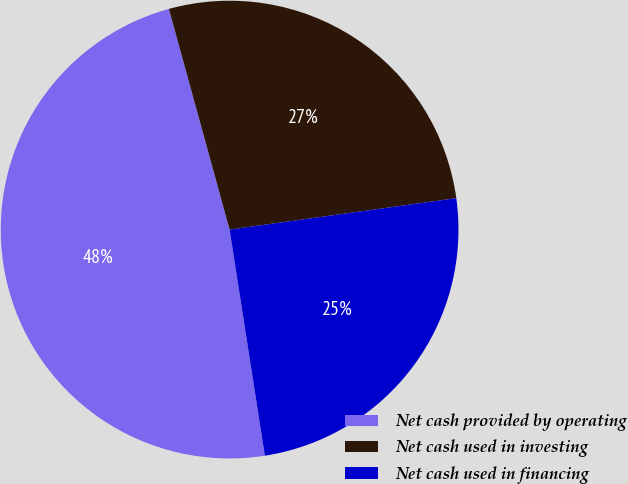Convert chart. <chart><loc_0><loc_0><loc_500><loc_500><pie_chart><fcel>Net cash provided by operating<fcel>Net cash used in investing<fcel>Net cash used in financing<nl><fcel>48.19%<fcel>27.08%<fcel>24.73%<nl></chart> 